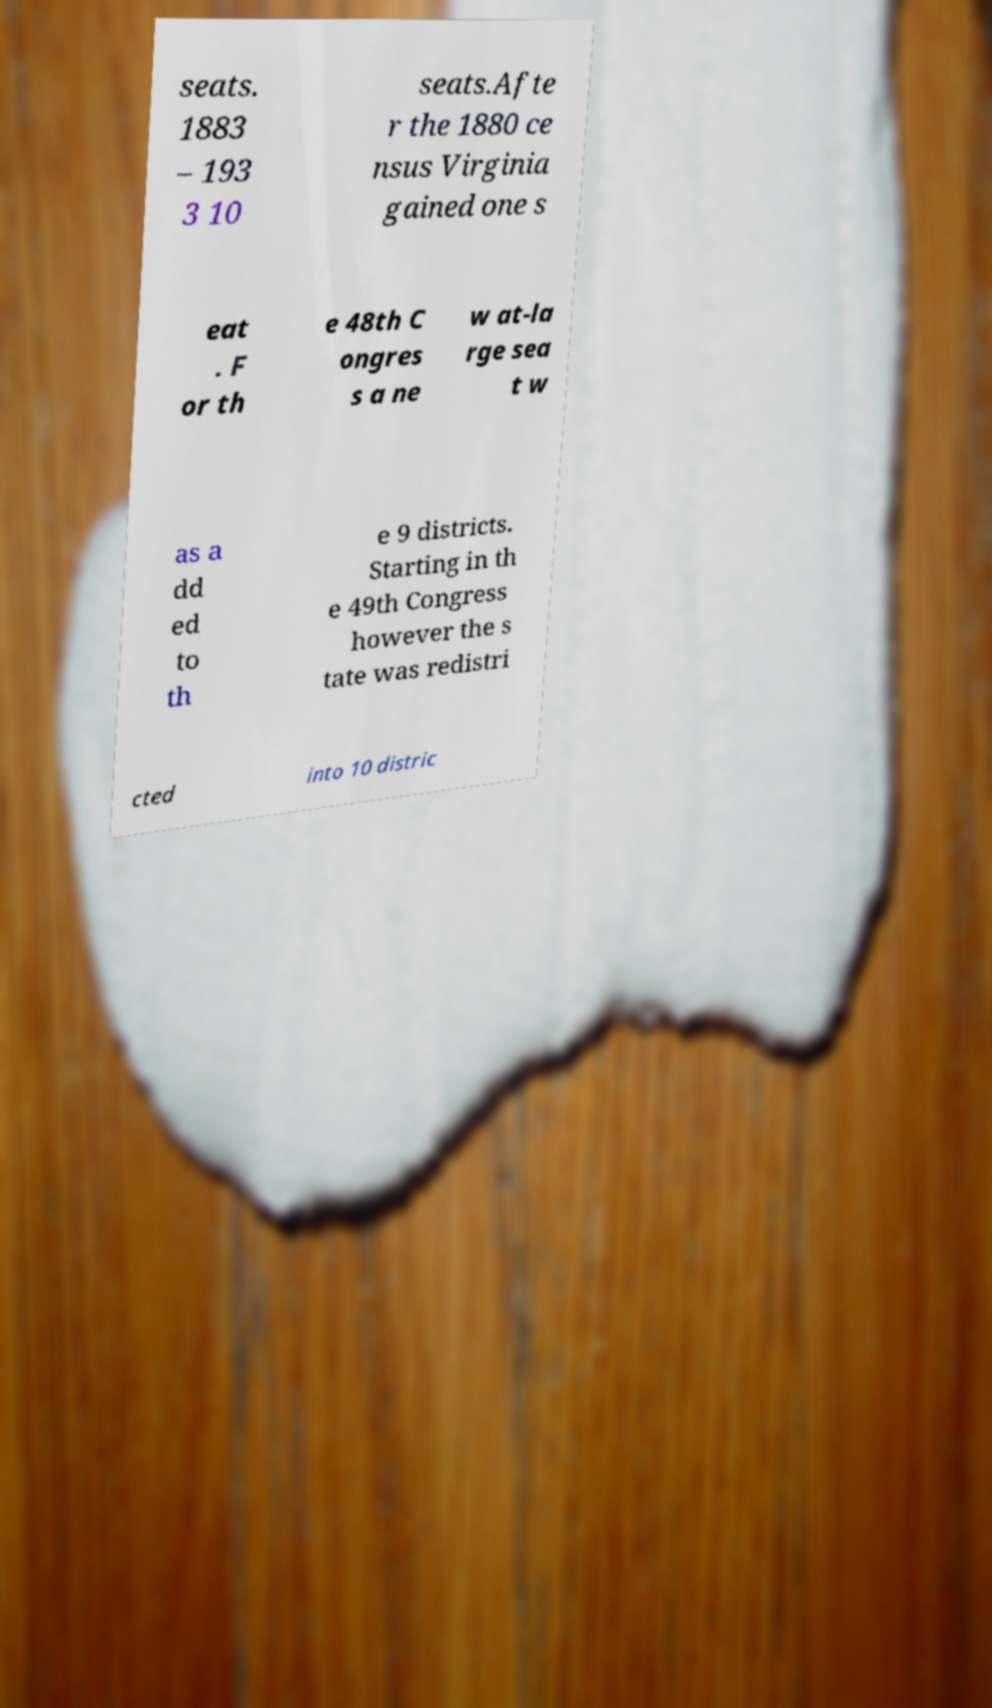I need the written content from this picture converted into text. Can you do that? seats. 1883 – 193 3 10 seats.Afte r the 1880 ce nsus Virginia gained one s eat . F or th e 48th C ongres s a ne w at-la rge sea t w as a dd ed to th e 9 districts. Starting in th e 49th Congress however the s tate was redistri cted into 10 distric 